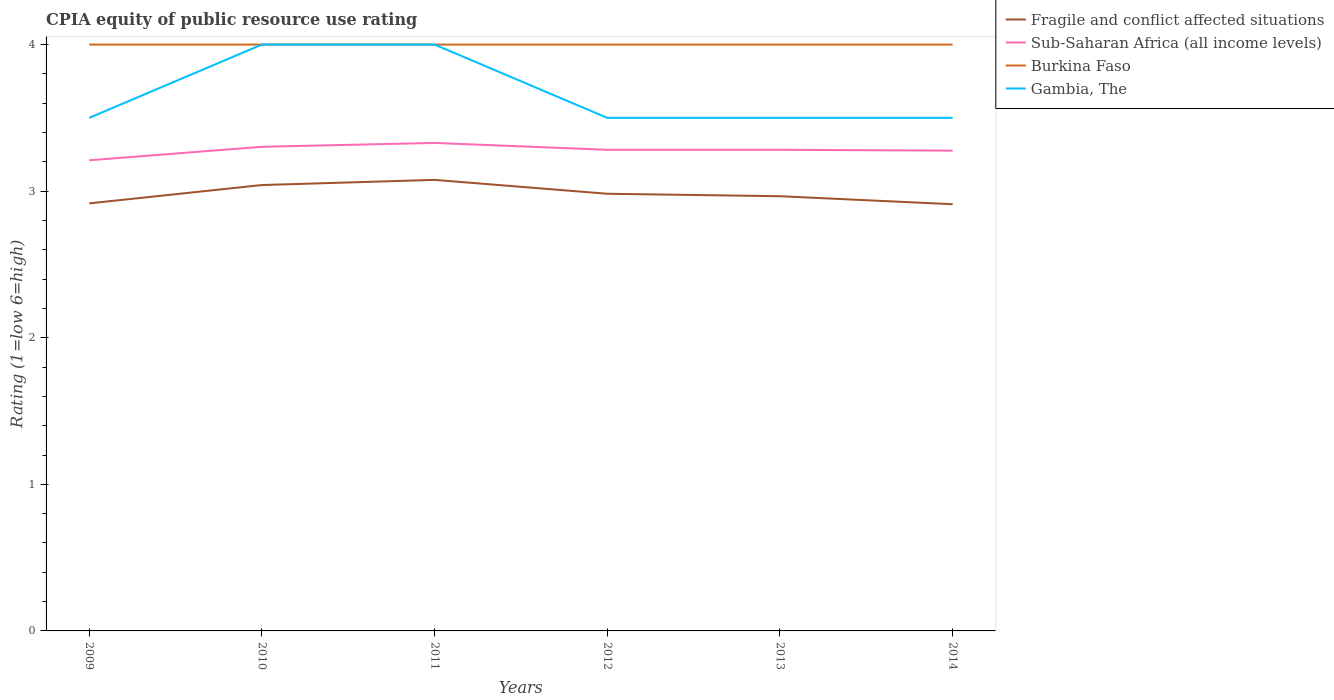How many different coloured lines are there?
Give a very brief answer. 4. Is the number of lines equal to the number of legend labels?
Your answer should be very brief. Yes. Across all years, what is the maximum CPIA rating in Burkina Faso?
Offer a terse response. 4. What is the difference between the highest and the second highest CPIA rating in Fragile and conflict affected situations?
Ensure brevity in your answer.  0.17. What is the difference between the highest and the lowest CPIA rating in Burkina Faso?
Make the answer very short. 0. How many years are there in the graph?
Offer a very short reply. 6. Does the graph contain grids?
Provide a short and direct response. No. What is the title of the graph?
Offer a terse response. CPIA equity of public resource use rating. What is the label or title of the X-axis?
Your response must be concise. Years. What is the label or title of the Y-axis?
Make the answer very short. Rating (1=low 6=high). What is the Rating (1=low 6=high) in Fragile and conflict affected situations in 2009?
Make the answer very short. 2.92. What is the Rating (1=low 6=high) in Sub-Saharan Africa (all income levels) in 2009?
Offer a terse response. 3.21. What is the Rating (1=low 6=high) of Burkina Faso in 2009?
Keep it short and to the point. 4. What is the Rating (1=low 6=high) of Fragile and conflict affected situations in 2010?
Provide a succinct answer. 3.04. What is the Rating (1=low 6=high) of Sub-Saharan Africa (all income levels) in 2010?
Offer a very short reply. 3.3. What is the Rating (1=low 6=high) in Burkina Faso in 2010?
Keep it short and to the point. 4. What is the Rating (1=low 6=high) in Gambia, The in 2010?
Your answer should be compact. 4. What is the Rating (1=low 6=high) in Fragile and conflict affected situations in 2011?
Offer a very short reply. 3.08. What is the Rating (1=low 6=high) of Sub-Saharan Africa (all income levels) in 2011?
Ensure brevity in your answer.  3.33. What is the Rating (1=low 6=high) of Fragile and conflict affected situations in 2012?
Keep it short and to the point. 2.98. What is the Rating (1=low 6=high) in Sub-Saharan Africa (all income levels) in 2012?
Provide a short and direct response. 3.28. What is the Rating (1=low 6=high) of Gambia, The in 2012?
Offer a terse response. 3.5. What is the Rating (1=low 6=high) in Fragile and conflict affected situations in 2013?
Give a very brief answer. 2.97. What is the Rating (1=low 6=high) in Sub-Saharan Africa (all income levels) in 2013?
Provide a short and direct response. 3.28. What is the Rating (1=low 6=high) in Gambia, The in 2013?
Your response must be concise. 3.5. What is the Rating (1=low 6=high) of Fragile and conflict affected situations in 2014?
Ensure brevity in your answer.  2.91. What is the Rating (1=low 6=high) of Sub-Saharan Africa (all income levels) in 2014?
Provide a succinct answer. 3.28. Across all years, what is the maximum Rating (1=low 6=high) in Fragile and conflict affected situations?
Give a very brief answer. 3.08. Across all years, what is the maximum Rating (1=low 6=high) of Sub-Saharan Africa (all income levels)?
Make the answer very short. 3.33. Across all years, what is the maximum Rating (1=low 6=high) of Burkina Faso?
Keep it short and to the point. 4. Across all years, what is the minimum Rating (1=low 6=high) in Fragile and conflict affected situations?
Make the answer very short. 2.91. Across all years, what is the minimum Rating (1=low 6=high) in Sub-Saharan Africa (all income levels)?
Your answer should be very brief. 3.21. Across all years, what is the minimum Rating (1=low 6=high) of Burkina Faso?
Offer a very short reply. 4. What is the total Rating (1=low 6=high) of Fragile and conflict affected situations in the graph?
Your answer should be very brief. 17.89. What is the total Rating (1=low 6=high) of Sub-Saharan Africa (all income levels) in the graph?
Your answer should be compact. 19.68. What is the total Rating (1=low 6=high) of Gambia, The in the graph?
Your response must be concise. 22. What is the difference between the Rating (1=low 6=high) in Fragile and conflict affected situations in 2009 and that in 2010?
Keep it short and to the point. -0.12. What is the difference between the Rating (1=low 6=high) in Sub-Saharan Africa (all income levels) in 2009 and that in 2010?
Provide a succinct answer. -0.09. What is the difference between the Rating (1=low 6=high) in Gambia, The in 2009 and that in 2010?
Your answer should be compact. -0.5. What is the difference between the Rating (1=low 6=high) in Fragile and conflict affected situations in 2009 and that in 2011?
Your answer should be very brief. -0.16. What is the difference between the Rating (1=low 6=high) of Sub-Saharan Africa (all income levels) in 2009 and that in 2011?
Make the answer very short. -0.12. What is the difference between the Rating (1=low 6=high) of Gambia, The in 2009 and that in 2011?
Your response must be concise. -0.5. What is the difference between the Rating (1=low 6=high) in Fragile and conflict affected situations in 2009 and that in 2012?
Your answer should be very brief. -0.07. What is the difference between the Rating (1=low 6=high) in Sub-Saharan Africa (all income levels) in 2009 and that in 2012?
Make the answer very short. -0.07. What is the difference between the Rating (1=low 6=high) in Gambia, The in 2009 and that in 2012?
Provide a succinct answer. 0. What is the difference between the Rating (1=low 6=high) of Fragile and conflict affected situations in 2009 and that in 2013?
Your response must be concise. -0.05. What is the difference between the Rating (1=low 6=high) in Sub-Saharan Africa (all income levels) in 2009 and that in 2013?
Ensure brevity in your answer.  -0.07. What is the difference between the Rating (1=low 6=high) in Gambia, The in 2009 and that in 2013?
Keep it short and to the point. 0. What is the difference between the Rating (1=low 6=high) of Fragile and conflict affected situations in 2009 and that in 2014?
Offer a terse response. 0.01. What is the difference between the Rating (1=low 6=high) of Sub-Saharan Africa (all income levels) in 2009 and that in 2014?
Ensure brevity in your answer.  -0.07. What is the difference between the Rating (1=low 6=high) in Fragile and conflict affected situations in 2010 and that in 2011?
Offer a very short reply. -0.04. What is the difference between the Rating (1=low 6=high) in Sub-Saharan Africa (all income levels) in 2010 and that in 2011?
Ensure brevity in your answer.  -0.03. What is the difference between the Rating (1=low 6=high) in Fragile and conflict affected situations in 2010 and that in 2012?
Provide a short and direct response. 0.06. What is the difference between the Rating (1=low 6=high) in Sub-Saharan Africa (all income levels) in 2010 and that in 2012?
Give a very brief answer. 0.02. What is the difference between the Rating (1=low 6=high) in Gambia, The in 2010 and that in 2012?
Your response must be concise. 0.5. What is the difference between the Rating (1=low 6=high) of Fragile and conflict affected situations in 2010 and that in 2013?
Provide a succinct answer. 0.08. What is the difference between the Rating (1=low 6=high) in Sub-Saharan Africa (all income levels) in 2010 and that in 2013?
Your answer should be very brief. 0.02. What is the difference between the Rating (1=low 6=high) of Fragile and conflict affected situations in 2010 and that in 2014?
Keep it short and to the point. 0.13. What is the difference between the Rating (1=low 6=high) in Sub-Saharan Africa (all income levels) in 2010 and that in 2014?
Your response must be concise. 0.03. What is the difference between the Rating (1=low 6=high) of Burkina Faso in 2010 and that in 2014?
Offer a very short reply. 0. What is the difference between the Rating (1=low 6=high) of Fragile and conflict affected situations in 2011 and that in 2012?
Keep it short and to the point. 0.09. What is the difference between the Rating (1=low 6=high) of Sub-Saharan Africa (all income levels) in 2011 and that in 2012?
Provide a succinct answer. 0.05. What is the difference between the Rating (1=low 6=high) of Burkina Faso in 2011 and that in 2012?
Offer a terse response. 0. What is the difference between the Rating (1=low 6=high) of Fragile and conflict affected situations in 2011 and that in 2013?
Your response must be concise. 0.11. What is the difference between the Rating (1=low 6=high) in Sub-Saharan Africa (all income levels) in 2011 and that in 2013?
Your response must be concise. 0.05. What is the difference between the Rating (1=low 6=high) of Burkina Faso in 2011 and that in 2013?
Ensure brevity in your answer.  0. What is the difference between the Rating (1=low 6=high) in Gambia, The in 2011 and that in 2013?
Offer a terse response. 0.5. What is the difference between the Rating (1=low 6=high) of Fragile and conflict affected situations in 2011 and that in 2014?
Provide a succinct answer. 0.17. What is the difference between the Rating (1=low 6=high) of Sub-Saharan Africa (all income levels) in 2011 and that in 2014?
Your response must be concise. 0.05. What is the difference between the Rating (1=low 6=high) of Burkina Faso in 2011 and that in 2014?
Keep it short and to the point. 0. What is the difference between the Rating (1=low 6=high) of Fragile and conflict affected situations in 2012 and that in 2013?
Ensure brevity in your answer.  0.02. What is the difference between the Rating (1=low 6=high) of Gambia, The in 2012 and that in 2013?
Make the answer very short. 0. What is the difference between the Rating (1=low 6=high) in Fragile and conflict affected situations in 2012 and that in 2014?
Offer a terse response. 0.07. What is the difference between the Rating (1=low 6=high) of Sub-Saharan Africa (all income levels) in 2012 and that in 2014?
Your answer should be very brief. 0.01. What is the difference between the Rating (1=low 6=high) of Burkina Faso in 2012 and that in 2014?
Keep it short and to the point. 0. What is the difference between the Rating (1=low 6=high) of Fragile and conflict affected situations in 2013 and that in 2014?
Ensure brevity in your answer.  0.05. What is the difference between the Rating (1=low 6=high) in Sub-Saharan Africa (all income levels) in 2013 and that in 2014?
Your answer should be compact. 0.01. What is the difference between the Rating (1=low 6=high) in Burkina Faso in 2013 and that in 2014?
Offer a very short reply. 0. What is the difference between the Rating (1=low 6=high) of Fragile and conflict affected situations in 2009 and the Rating (1=low 6=high) of Sub-Saharan Africa (all income levels) in 2010?
Your answer should be very brief. -0.39. What is the difference between the Rating (1=low 6=high) in Fragile and conflict affected situations in 2009 and the Rating (1=low 6=high) in Burkina Faso in 2010?
Your response must be concise. -1.08. What is the difference between the Rating (1=low 6=high) in Fragile and conflict affected situations in 2009 and the Rating (1=low 6=high) in Gambia, The in 2010?
Give a very brief answer. -1.08. What is the difference between the Rating (1=low 6=high) of Sub-Saharan Africa (all income levels) in 2009 and the Rating (1=low 6=high) of Burkina Faso in 2010?
Your answer should be very brief. -0.79. What is the difference between the Rating (1=low 6=high) of Sub-Saharan Africa (all income levels) in 2009 and the Rating (1=low 6=high) of Gambia, The in 2010?
Offer a terse response. -0.79. What is the difference between the Rating (1=low 6=high) in Fragile and conflict affected situations in 2009 and the Rating (1=low 6=high) in Sub-Saharan Africa (all income levels) in 2011?
Give a very brief answer. -0.41. What is the difference between the Rating (1=low 6=high) in Fragile and conflict affected situations in 2009 and the Rating (1=low 6=high) in Burkina Faso in 2011?
Give a very brief answer. -1.08. What is the difference between the Rating (1=low 6=high) of Fragile and conflict affected situations in 2009 and the Rating (1=low 6=high) of Gambia, The in 2011?
Your answer should be very brief. -1.08. What is the difference between the Rating (1=low 6=high) of Sub-Saharan Africa (all income levels) in 2009 and the Rating (1=low 6=high) of Burkina Faso in 2011?
Make the answer very short. -0.79. What is the difference between the Rating (1=low 6=high) in Sub-Saharan Africa (all income levels) in 2009 and the Rating (1=low 6=high) in Gambia, The in 2011?
Your answer should be compact. -0.79. What is the difference between the Rating (1=low 6=high) in Burkina Faso in 2009 and the Rating (1=low 6=high) in Gambia, The in 2011?
Offer a terse response. 0. What is the difference between the Rating (1=low 6=high) in Fragile and conflict affected situations in 2009 and the Rating (1=low 6=high) in Sub-Saharan Africa (all income levels) in 2012?
Your answer should be compact. -0.37. What is the difference between the Rating (1=low 6=high) in Fragile and conflict affected situations in 2009 and the Rating (1=low 6=high) in Burkina Faso in 2012?
Offer a terse response. -1.08. What is the difference between the Rating (1=low 6=high) in Fragile and conflict affected situations in 2009 and the Rating (1=low 6=high) in Gambia, The in 2012?
Keep it short and to the point. -0.58. What is the difference between the Rating (1=low 6=high) in Sub-Saharan Africa (all income levels) in 2009 and the Rating (1=low 6=high) in Burkina Faso in 2012?
Your answer should be compact. -0.79. What is the difference between the Rating (1=low 6=high) of Sub-Saharan Africa (all income levels) in 2009 and the Rating (1=low 6=high) of Gambia, The in 2012?
Your response must be concise. -0.29. What is the difference between the Rating (1=low 6=high) in Burkina Faso in 2009 and the Rating (1=low 6=high) in Gambia, The in 2012?
Your answer should be compact. 0.5. What is the difference between the Rating (1=low 6=high) of Fragile and conflict affected situations in 2009 and the Rating (1=low 6=high) of Sub-Saharan Africa (all income levels) in 2013?
Provide a short and direct response. -0.37. What is the difference between the Rating (1=low 6=high) in Fragile and conflict affected situations in 2009 and the Rating (1=low 6=high) in Burkina Faso in 2013?
Give a very brief answer. -1.08. What is the difference between the Rating (1=low 6=high) in Fragile and conflict affected situations in 2009 and the Rating (1=low 6=high) in Gambia, The in 2013?
Offer a very short reply. -0.58. What is the difference between the Rating (1=low 6=high) in Sub-Saharan Africa (all income levels) in 2009 and the Rating (1=low 6=high) in Burkina Faso in 2013?
Provide a short and direct response. -0.79. What is the difference between the Rating (1=low 6=high) in Sub-Saharan Africa (all income levels) in 2009 and the Rating (1=low 6=high) in Gambia, The in 2013?
Your response must be concise. -0.29. What is the difference between the Rating (1=low 6=high) of Burkina Faso in 2009 and the Rating (1=low 6=high) of Gambia, The in 2013?
Offer a very short reply. 0.5. What is the difference between the Rating (1=low 6=high) in Fragile and conflict affected situations in 2009 and the Rating (1=low 6=high) in Sub-Saharan Africa (all income levels) in 2014?
Provide a succinct answer. -0.36. What is the difference between the Rating (1=low 6=high) in Fragile and conflict affected situations in 2009 and the Rating (1=low 6=high) in Burkina Faso in 2014?
Offer a terse response. -1.08. What is the difference between the Rating (1=low 6=high) in Fragile and conflict affected situations in 2009 and the Rating (1=low 6=high) in Gambia, The in 2014?
Make the answer very short. -0.58. What is the difference between the Rating (1=low 6=high) in Sub-Saharan Africa (all income levels) in 2009 and the Rating (1=low 6=high) in Burkina Faso in 2014?
Keep it short and to the point. -0.79. What is the difference between the Rating (1=low 6=high) of Sub-Saharan Africa (all income levels) in 2009 and the Rating (1=low 6=high) of Gambia, The in 2014?
Give a very brief answer. -0.29. What is the difference between the Rating (1=low 6=high) in Burkina Faso in 2009 and the Rating (1=low 6=high) in Gambia, The in 2014?
Ensure brevity in your answer.  0.5. What is the difference between the Rating (1=low 6=high) in Fragile and conflict affected situations in 2010 and the Rating (1=low 6=high) in Sub-Saharan Africa (all income levels) in 2011?
Offer a very short reply. -0.29. What is the difference between the Rating (1=low 6=high) in Fragile and conflict affected situations in 2010 and the Rating (1=low 6=high) in Burkina Faso in 2011?
Offer a terse response. -0.96. What is the difference between the Rating (1=low 6=high) of Fragile and conflict affected situations in 2010 and the Rating (1=low 6=high) of Gambia, The in 2011?
Your answer should be compact. -0.96. What is the difference between the Rating (1=low 6=high) of Sub-Saharan Africa (all income levels) in 2010 and the Rating (1=low 6=high) of Burkina Faso in 2011?
Give a very brief answer. -0.7. What is the difference between the Rating (1=low 6=high) of Sub-Saharan Africa (all income levels) in 2010 and the Rating (1=low 6=high) of Gambia, The in 2011?
Your response must be concise. -0.7. What is the difference between the Rating (1=low 6=high) of Fragile and conflict affected situations in 2010 and the Rating (1=low 6=high) of Sub-Saharan Africa (all income levels) in 2012?
Your response must be concise. -0.24. What is the difference between the Rating (1=low 6=high) of Fragile and conflict affected situations in 2010 and the Rating (1=low 6=high) of Burkina Faso in 2012?
Ensure brevity in your answer.  -0.96. What is the difference between the Rating (1=low 6=high) in Fragile and conflict affected situations in 2010 and the Rating (1=low 6=high) in Gambia, The in 2012?
Offer a terse response. -0.46. What is the difference between the Rating (1=low 6=high) in Sub-Saharan Africa (all income levels) in 2010 and the Rating (1=low 6=high) in Burkina Faso in 2012?
Keep it short and to the point. -0.7. What is the difference between the Rating (1=low 6=high) of Sub-Saharan Africa (all income levels) in 2010 and the Rating (1=low 6=high) of Gambia, The in 2012?
Ensure brevity in your answer.  -0.2. What is the difference between the Rating (1=low 6=high) in Fragile and conflict affected situations in 2010 and the Rating (1=low 6=high) in Sub-Saharan Africa (all income levels) in 2013?
Offer a terse response. -0.24. What is the difference between the Rating (1=low 6=high) of Fragile and conflict affected situations in 2010 and the Rating (1=low 6=high) of Burkina Faso in 2013?
Provide a short and direct response. -0.96. What is the difference between the Rating (1=low 6=high) in Fragile and conflict affected situations in 2010 and the Rating (1=low 6=high) in Gambia, The in 2013?
Your answer should be very brief. -0.46. What is the difference between the Rating (1=low 6=high) in Sub-Saharan Africa (all income levels) in 2010 and the Rating (1=low 6=high) in Burkina Faso in 2013?
Provide a succinct answer. -0.7. What is the difference between the Rating (1=low 6=high) in Sub-Saharan Africa (all income levels) in 2010 and the Rating (1=low 6=high) in Gambia, The in 2013?
Offer a terse response. -0.2. What is the difference between the Rating (1=low 6=high) in Fragile and conflict affected situations in 2010 and the Rating (1=low 6=high) in Sub-Saharan Africa (all income levels) in 2014?
Provide a succinct answer. -0.23. What is the difference between the Rating (1=low 6=high) of Fragile and conflict affected situations in 2010 and the Rating (1=low 6=high) of Burkina Faso in 2014?
Offer a terse response. -0.96. What is the difference between the Rating (1=low 6=high) of Fragile and conflict affected situations in 2010 and the Rating (1=low 6=high) of Gambia, The in 2014?
Make the answer very short. -0.46. What is the difference between the Rating (1=low 6=high) in Sub-Saharan Africa (all income levels) in 2010 and the Rating (1=low 6=high) in Burkina Faso in 2014?
Your answer should be compact. -0.7. What is the difference between the Rating (1=low 6=high) of Sub-Saharan Africa (all income levels) in 2010 and the Rating (1=low 6=high) of Gambia, The in 2014?
Provide a succinct answer. -0.2. What is the difference between the Rating (1=low 6=high) of Burkina Faso in 2010 and the Rating (1=low 6=high) of Gambia, The in 2014?
Your answer should be very brief. 0.5. What is the difference between the Rating (1=low 6=high) in Fragile and conflict affected situations in 2011 and the Rating (1=low 6=high) in Sub-Saharan Africa (all income levels) in 2012?
Keep it short and to the point. -0.21. What is the difference between the Rating (1=low 6=high) in Fragile and conflict affected situations in 2011 and the Rating (1=low 6=high) in Burkina Faso in 2012?
Provide a succinct answer. -0.92. What is the difference between the Rating (1=low 6=high) in Fragile and conflict affected situations in 2011 and the Rating (1=low 6=high) in Gambia, The in 2012?
Your answer should be compact. -0.42. What is the difference between the Rating (1=low 6=high) in Sub-Saharan Africa (all income levels) in 2011 and the Rating (1=low 6=high) in Burkina Faso in 2012?
Keep it short and to the point. -0.67. What is the difference between the Rating (1=low 6=high) of Sub-Saharan Africa (all income levels) in 2011 and the Rating (1=low 6=high) of Gambia, The in 2012?
Your response must be concise. -0.17. What is the difference between the Rating (1=low 6=high) in Fragile and conflict affected situations in 2011 and the Rating (1=low 6=high) in Sub-Saharan Africa (all income levels) in 2013?
Provide a short and direct response. -0.21. What is the difference between the Rating (1=low 6=high) in Fragile and conflict affected situations in 2011 and the Rating (1=low 6=high) in Burkina Faso in 2013?
Your answer should be compact. -0.92. What is the difference between the Rating (1=low 6=high) in Fragile and conflict affected situations in 2011 and the Rating (1=low 6=high) in Gambia, The in 2013?
Make the answer very short. -0.42. What is the difference between the Rating (1=low 6=high) of Sub-Saharan Africa (all income levels) in 2011 and the Rating (1=low 6=high) of Burkina Faso in 2013?
Offer a terse response. -0.67. What is the difference between the Rating (1=low 6=high) of Sub-Saharan Africa (all income levels) in 2011 and the Rating (1=low 6=high) of Gambia, The in 2013?
Provide a succinct answer. -0.17. What is the difference between the Rating (1=low 6=high) of Burkina Faso in 2011 and the Rating (1=low 6=high) of Gambia, The in 2013?
Offer a very short reply. 0.5. What is the difference between the Rating (1=low 6=high) in Fragile and conflict affected situations in 2011 and the Rating (1=low 6=high) in Sub-Saharan Africa (all income levels) in 2014?
Provide a short and direct response. -0.2. What is the difference between the Rating (1=low 6=high) of Fragile and conflict affected situations in 2011 and the Rating (1=low 6=high) of Burkina Faso in 2014?
Keep it short and to the point. -0.92. What is the difference between the Rating (1=low 6=high) of Fragile and conflict affected situations in 2011 and the Rating (1=low 6=high) of Gambia, The in 2014?
Your response must be concise. -0.42. What is the difference between the Rating (1=low 6=high) in Sub-Saharan Africa (all income levels) in 2011 and the Rating (1=low 6=high) in Burkina Faso in 2014?
Your answer should be compact. -0.67. What is the difference between the Rating (1=low 6=high) in Sub-Saharan Africa (all income levels) in 2011 and the Rating (1=low 6=high) in Gambia, The in 2014?
Offer a terse response. -0.17. What is the difference between the Rating (1=low 6=high) of Fragile and conflict affected situations in 2012 and the Rating (1=low 6=high) of Sub-Saharan Africa (all income levels) in 2013?
Keep it short and to the point. -0.3. What is the difference between the Rating (1=low 6=high) in Fragile and conflict affected situations in 2012 and the Rating (1=low 6=high) in Burkina Faso in 2013?
Provide a succinct answer. -1.02. What is the difference between the Rating (1=low 6=high) in Fragile and conflict affected situations in 2012 and the Rating (1=low 6=high) in Gambia, The in 2013?
Your response must be concise. -0.52. What is the difference between the Rating (1=low 6=high) of Sub-Saharan Africa (all income levels) in 2012 and the Rating (1=low 6=high) of Burkina Faso in 2013?
Your answer should be compact. -0.72. What is the difference between the Rating (1=low 6=high) of Sub-Saharan Africa (all income levels) in 2012 and the Rating (1=low 6=high) of Gambia, The in 2013?
Offer a terse response. -0.22. What is the difference between the Rating (1=low 6=high) in Burkina Faso in 2012 and the Rating (1=low 6=high) in Gambia, The in 2013?
Your answer should be very brief. 0.5. What is the difference between the Rating (1=low 6=high) of Fragile and conflict affected situations in 2012 and the Rating (1=low 6=high) of Sub-Saharan Africa (all income levels) in 2014?
Your answer should be very brief. -0.29. What is the difference between the Rating (1=low 6=high) of Fragile and conflict affected situations in 2012 and the Rating (1=low 6=high) of Burkina Faso in 2014?
Your response must be concise. -1.02. What is the difference between the Rating (1=low 6=high) of Fragile and conflict affected situations in 2012 and the Rating (1=low 6=high) of Gambia, The in 2014?
Ensure brevity in your answer.  -0.52. What is the difference between the Rating (1=low 6=high) of Sub-Saharan Africa (all income levels) in 2012 and the Rating (1=low 6=high) of Burkina Faso in 2014?
Provide a short and direct response. -0.72. What is the difference between the Rating (1=low 6=high) of Sub-Saharan Africa (all income levels) in 2012 and the Rating (1=low 6=high) of Gambia, The in 2014?
Keep it short and to the point. -0.22. What is the difference between the Rating (1=low 6=high) in Burkina Faso in 2012 and the Rating (1=low 6=high) in Gambia, The in 2014?
Give a very brief answer. 0.5. What is the difference between the Rating (1=low 6=high) of Fragile and conflict affected situations in 2013 and the Rating (1=low 6=high) of Sub-Saharan Africa (all income levels) in 2014?
Your answer should be compact. -0.31. What is the difference between the Rating (1=low 6=high) of Fragile and conflict affected situations in 2013 and the Rating (1=low 6=high) of Burkina Faso in 2014?
Give a very brief answer. -1.03. What is the difference between the Rating (1=low 6=high) of Fragile and conflict affected situations in 2013 and the Rating (1=low 6=high) of Gambia, The in 2014?
Your response must be concise. -0.53. What is the difference between the Rating (1=low 6=high) in Sub-Saharan Africa (all income levels) in 2013 and the Rating (1=low 6=high) in Burkina Faso in 2014?
Make the answer very short. -0.72. What is the difference between the Rating (1=low 6=high) in Sub-Saharan Africa (all income levels) in 2013 and the Rating (1=low 6=high) in Gambia, The in 2014?
Ensure brevity in your answer.  -0.22. What is the difference between the Rating (1=low 6=high) of Burkina Faso in 2013 and the Rating (1=low 6=high) of Gambia, The in 2014?
Your response must be concise. 0.5. What is the average Rating (1=low 6=high) of Fragile and conflict affected situations per year?
Provide a short and direct response. 2.98. What is the average Rating (1=low 6=high) of Sub-Saharan Africa (all income levels) per year?
Your answer should be very brief. 3.28. What is the average Rating (1=low 6=high) in Burkina Faso per year?
Keep it short and to the point. 4. What is the average Rating (1=low 6=high) in Gambia, The per year?
Provide a succinct answer. 3.67. In the year 2009, what is the difference between the Rating (1=low 6=high) in Fragile and conflict affected situations and Rating (1=low 6=high) in Sub-Saharan Africa (all income levels)?
Ensure brevity in your answer.  -0.29. In the year 2009, what is the difference between the Rating (1=low 6=high) of Fragile and conflict affected situations and Rating (1=low 6=high) of Burkina Faso?
Provide a succinct answer. -1.08. In the year 2009, what is the difference between the Rating (1=low 6=high) in Fragile and conflict affected situations and Rating (1=low 6=high) in Gambia, The?
Ensure brevity in your answer.  -0.58. In the year 2009, what is the difference between the Rating (1=low 6=high) of Sub-Saharan Africa (all income levels) and Rating (1=low 6=high) of Burkina Faso?
Provide a succinct answer. -0.79. In the year 2009, what is the difference between the Rating (1=low 6=high) of Sub-Saharan Africa (all income levels) and Rating (1=low 6=high) of Gambia, The?
Your answer should be compact. -0.29. In the year 2010, what is the difference between the Rating (1=low 6=high) of Fragile and conflict affected situations and Rating (1=low 6=high) of Sub-Saharan Africa (all income levels)?
Give a very brief answer. -0.26. In the year 2010, what is the difference between the Rating (1=low 6=high) of Fragile and conflict affected situations and Rating (1=low 6=high) of Burkina Faso?
Your answer should be very brief. -0.96. In the year 2010, what is the difference between the Rating (1=low 6=high) in Fragile and conflict affected situations and Rating (1=low 6=high) in Gambia, The?
Your response must be concise. -0.96. In the year 2010, what is the difference between the Rating (1=low 6=high) of Sub-Saharan Africa (all income levels) and Rating (1=low 6=high) of Burkina Faso?
Your answer should be compact. -0.7. In the year 2010, what is the difference between the Rating (1=low 6=high) of Sub-Saharan Africa (all income levels) and Rating (1=low 6=high) of Gambia, The?
Your answer should be compact. -0.7. In the year 2011, what is the difference between the Rating (1=low 6=high) in Fragile and conflict affected situations and Rating (1=low 6=high) in Sub-Saharan Africa (all income levels)?
Keep it short and to the point. -0.25. In the year 2011, what is the difference between the Rating (1=low 6=high) of Fragile and conflict affected situations and Rating (1=low 6=high) of Burkina Faso?
Offer a terse response. -0.92. In the year 2011, what is the difference between the Rating (1=low 6=high) in Fragile and conflict affected situations and Rating (1=low 6=high) in Gambia, The?
Provide a succinct answer. -0.92. In the year 2011, what is the difference between the Rating (1=low 6=high) of Sub-Saharan Africa (all income levels) and Rating (1=low 6=high) of Burkina Faso?
Offer a very short reply. -0.67. In the year 2011, what is the difference between the Rating (1=low 6=high) in Sub-Saharan Africa (all income levels) and Rating (1=low 6=high) in Gambia, The?
Make the answer very short. -0.67. In the year 2012, what is the difference between the Rating (1=low 6=high) of Fragile and conflict affected situations and Rating (1=low 6=high) of Sub-Saharan Africa (all income levels)?
Provide a succinct answer. -0.3. In the year 2012, what is the difference between the Rating (1=low 6=high) in Fragile and conflict affected situations and Rating (1=low 6=high) in Burkina Faso?
Give a very brief answer. -1.02. In the year 2012, what is the difference between the Rating (1=low 6=high) in Fragile and conflict affected situations and Rating (1=low 6=high) in Gambia, The?
Your response must be concise. -0.52. In the year 2012, what is the difference between the Rating (1=low 6=high) of Sub-Saharan Africa (all income levels) and Rating (1=low 6=high) of Burkina Faso?
Offer a terse response. -0.72. In the year 2012, what is the difference between the Rating (1=low 6=high) of Sub-Saharan Africa (all income levels) and Rating (1=low 6=high) of Gambia, The?
Your answer should be very brief. -0.22. In the year 2012, what is the difference between the Rating (1=low 6=high) of Burkina Faso and Rating (1=low 6=high) of Gambia, The?
Provide a short and direct response. 0.5. In the year 2013, what is the difference between the Rating (1=low 6=high) of Fragile and conflict affected situations and Rating (1=low 6=high) of Sub-Saharan Africa (all income levels)?
Make the answer very short. -0.32. In the year 2013, what is the difference between the Rating (1=low 6=high) of Fragile and conflict affected situations and Rating (1=low 6=high) of Burkina Faso?
Make the answer very short. -1.03. In the year 2013, what is the difference between the Rating (1=low 6=high) of Fragile and conflict affected situations and Rating (1=low 6=high) of Gambia, The?
Offer a terse response. -0.53. In the year 2013, what is the difference between the Rating (1=low 6=high) in Sub-Saharan Africa (all income levels) and Rating (1=low 6=high) in Burkina Faso?
Provide a succinct answer. -0.72. In the year 2013, what is the difference between the Rating (1=low 6=high) of Sub-Saharan Africa (all income levels) and Rating (1=low 6=high) of Gambia, The?
Keep it short and to the point. -0.22. In the year 2013, what is the difference between the Rating (1=low 6=high) of Burkina Faso and Rating (1=low 6=high) of Gambia, The?
Offer a terse response. 0.5. In the year 2014, what is the difference between the Rating (1=low 6=high) of Fragile and conflict affected situations and Rating (1=low 6=high) of Sub-Saharan Africa (all income levels)?
Provide a succinct answer. -0.37. In the year 2014, what is the difference between the Rating (1=low 6=high) of Fragile and conflict affected situations and Rating (1=low 6=high) of Burkina Faso?
Give a very brief answer. -1.09. In the year 2014, what is the difference between the Rating (1=low 6=high) of Fragile and conflict affected situations and Rating (1=low 6=high) of Gambia, The?
Ensure brevity in your answer.  -0.59. In the year 2014, what is the difference between the Rating (1=low 6=high) in Sub-Saharan Africa (all income levels) and Rating (1=low 6=high) in Burkina Faso?
Your response must be concise. -0.72. In the year 2014, what is the difference between the Rating (1=low 6=high) of Sub-Saharan Africa (all income levels) and Rating (1=low 6=high) of Gambia, The?
Keep it short and to the point. -0.22. What is the ratio of the Rating (1=low 6=high) in Fragile and conflict affected situations in 2009 to that in 2010?
Offer a terse response. 0.96. What is the ratio of the Rating (1=low 6=high) in Sub-Saharan Africa (all income levels) in 2009 to that in 2010?
Keep it short and to the point. 0.97. What is the ratio of the Rating (1=low 6=high) in Fragile and conflict affected situations in 2009 to that in 2011?
Provide a succinct answer. 0.95. What is the ratio of the Rating (1=low 6=high) of Sub-Saharan Africa (all income levels) in 2009 to that in 2011?
Keep it short and to the point. 0.96. What is the ratio of the Rating (1=low 6=high) of Burkina Faso in 2009 to that in 2011?
Provide a short and direct response. 1. What is the ratio of the Rating (1=low 6=high) of Gambia, The in 2009 to that in 2011?
Make the answer very short. 0.88. What is the ratio of the Rating (1=low 6=high) of Fragile and conflict affected situations in 2009 to that in 2012?
Your response must be concise. 0.98. What is the ratio of the Rating (1=low 6=high) of Sub-Saharan Africa (all income levels) in 2009 to that in 2012?
Ensure brevity in your answer.  0.98. What is the ratio of the Rating (1=low 6=high) of Burkina Faso in 2009 to that in 2012?
Make the answer very short. 1. What is the ratio of the Rating (1=low 6=high) in Gambia, The in 2009 to that in 2012?
Offer a very short reply. 1. What is the ratio of the Rating (1=low 6=high) in Fragile and conflict affected situations in 2009 to that in 2013?
Make the answer very short. 0.98. What is the ratio of the Rating (1=low 6=high) of Sub-Saharan Africa (all income levels) in 2009 to that in 2013?
Provide a short and direct response. 0.98. What is the ratio of the Rating (1=low 6=high) of Burkina Faso in 2009 to that in 2013?
Offer a very short reply. 1. What is the ratio of the Rating (1=low 6=high) in Gambia, The in 2009 to that in 2013?
Provide a short and direct response. 1. What is the ratio of the Rating (1=low 6=high) of Sub-Saharan Africa (all income levels) in 2009 to that in 2014?
Offer a very short reply. 0.98. What is the ratio of the Rating (1=low 6=high) of Gambia, The in 2009 to that in 2014?
Provide a short and direct response. 1. What is the ratio of the Rating (1=low 6=high) of Fragile and conflict affected situations in 2010 to that in 2011?
Give a very brief answer. 0.99. What is the ratio of the Rating (1=low 6=high) of Sub-Saharan Africa (all income levels) in 2010 to that in 2011?
Provide a succinct answer. 0.99. What is the ratio of the Rating (1=low 6=high) of Fragile and conflict affected situations in 2010 to that in 2013?
Your response must be concise. 1.03. What is the ratio of the Rating (1=low 6=high) of Sub-Saharan Africa (all income levels) in 2010 to that in 2013?
Provide a short and direct response. 1.01. What is the ratio of the Rating (1=low 6=high) of Burkina Faso in 2010 to that in 2013?
Your answer should be compact. 1. What is the ratio of the Rating (1=low 6=high) in Gambia, The in 2010 to that in 2013?
Ensure brevity in your answer.  1.14. What is the ratio of the Rating (1=low 6=high) of Fragile and conflict affected situations in 2010 to that in 2014?
Offer a very short reply. 1.04. What is the ratio of the Rating (1=low 6=high) of Burkina Faso in 2010 to that in 2014?
Your response must be concise. 1. What is the ratio of the Rating (1=low 6=high) of Fragile and conflict affected situations in 2011 to that in 2012?
Your answer should be very brief. 1.03. What is the ratio of the Rating (1=low 6=high) in Sub-Saharan Africa (all income levels) in 2011 to that in 2012?
Offer a very short reply. 1.01. What is the ratio of the Rating (1=low 6=high) in Burkina Faso in 2011 to that in 2012?
Provide a succinct answer. 1. What is the ratio of the Rating (1=low 6=high) in Fragile and conflict affected situations in 2011 to that in 2013?
Ensure brevity in your answer.  1.04. What is the ratio of the Rating (1=low 6=high) of Sub-Saharan Africa (all income levels) in 2011 to that in 2013?
Ensure brevity in your answer.  1.01. What is the ratio of the Rating (1=low 6=high) of Fragile and conflict affected situations in 2011 to that in 2014?
Your response must be concise. 1.06. What is the ratio of the Rating (1=low 6=high) in Sub-Saharan Africa (all income levels) in 2011 to that in 2014?
Provide a succinct answer. 1.02. What is the ratio of the Rating (1=low 6=high) in Burkina Faso in 2011 to that in 2014?
Offer a very short reply. 1. What is the ratio of the Rating (1=low 6=high) in Fragile and conflict affected situations in 2012 to that in 2013?
Offer a terse response. 1.01. What is the ratio of the Rating (1=low 6=high) in Fragile and conflict affected situations in 2012 to that in 2014?
Offer a terse response. 1.02. What is the ratio of the Rating (1=low 6=high) in Burkina Faso in 2012 to that in 2014?
Your answer should be very brief. 1. What is the ratio of the Rating (1=low 6=high) of Fragile and conflict affected situations in 2013 to that in 2014?
Provide a succinct answer. 1.02. What is the ratio of the Rating (1=low 6=high) of Sub-Saharan Africa (all income levels) in 2013 to that in 2014?
Offer a very short reply. 1. What is the difference between the highest and the second highest Rating (1=low 6=high) in Fragile and conflict affected situations?
Offer a terse response. 0.04. What is the difference between the highest and the second highest Rating (1=low 6=high) in Sub-Saharan Africa (all income levels)?
Your answer should be very brief. 0.03. What is the difference between the highest and the second highest Rating (1=low 6=high) in Burkina Faso?
Your response must be concise. 0. What is the difference between the highest and the lowest Rating (1=low 6=high) of Fragile and conflict affected situations?
Your answer should be very brief. 0.17. What is the difference between the highest and the lowest Rating (1=low 6=high) of Sub-Saharan Africa (all income levels)?
Give a very brief answer. 0.12. What is the difference between the highest and the lowest Rating (1=low 6=high) in Burkina Faso?
Offer a very short reply. 0. What is the difference between the highest and the lowest Rating (1=low 6=high) in Gambia, The?
Offer a terse response. 0.5. 